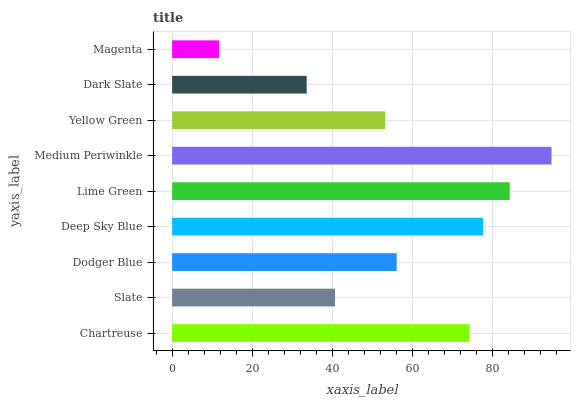Is Magenta the minimum?
Answer yes or no. Yes. Is Medium Periwinkle the maximum?
Answer yes or no. Yes. Is Slate the minimum?
Answer yes or no. No. Is Slate the maximum?
Answer yes or no. No. Is Chartreuse greater than Slate?
Answer yes or no. Yes. Is Slate less than Chartreuse?
Answer yes or no. Yes. Is Slate greater than Chartreuse?
Answer yes or no. No. Is Chartreuse less than Slate?
Answer yes or no. No. Is Dodger Blue the high median?
Answer yes or no. Yes. Is Dodger Blue the low median?
Answer yes or no. Yes. Is Chartreuse the high median?
Answer yes or no. No. Is Lime Green the low median?
Answer yes or no. No. 